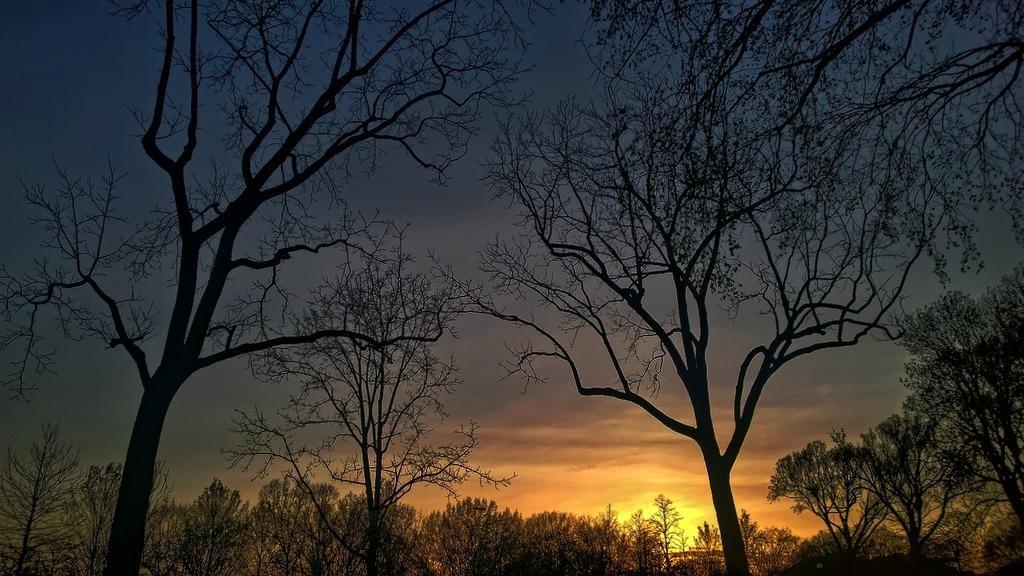Could you give a brief overview of what you see in this image? In this image I can see few trees and the sky is in yellow, orange, grey and blue color. 